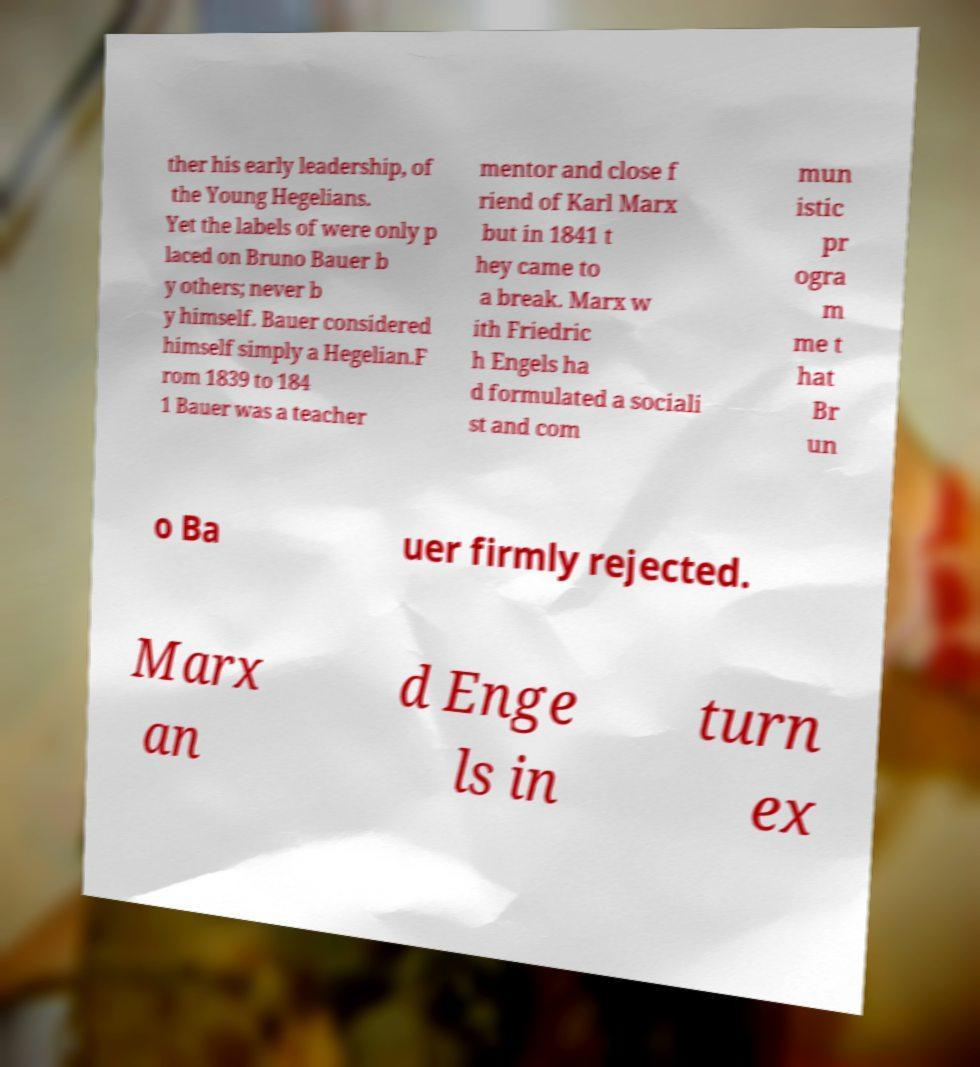Please identify and transcribe the text found in this image. ther his early leadership, of the Young Hegelians. Yet the labels of were only p laced on Bruno Bauer b y others; never b y himself. Bauer considered himself simply a Hegelian.F rom 1839 to 184 1 Bauer was a teacher mentor and close f riend of Karl Marx but in 1841 t hey came to a break. Marx w ith Friedric h Engels ha d formulated a sociali st and com mun istic pr ogra m me t hat Br un o Ba uer firmly rejected. Marx an d Enge ls in turn ex 